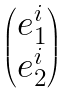<formula> <loc_0><loc_0><loc_500><loc_500>\begin{pmatrix} e ^ { i } _ { 1 } \\ e ^ { i } _ { 2 } \end{pmatrix}</formula> 